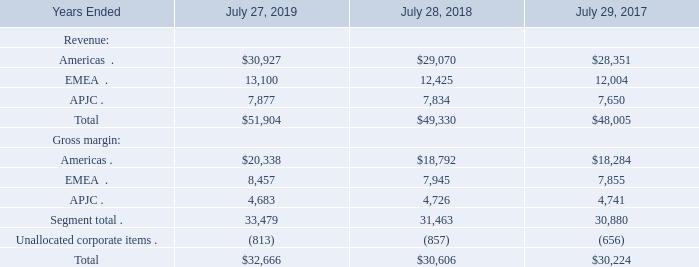(a) Revenue and Gross Margin by Segment
We conduct business globally and are managed on a geographic basis consisting of three segments: the Americas, EMEA, and APJC. Our management makes financial decisions and allocates resources based on the information it receives from our internal management system. Sales are attributed to a segment based on the ordering location of the customer. We do not allocate research and development, sales and marketing, or general and administrative expenses to our segments in this internal management system because management does not include the information in our measurement of the performance of the operating segments. In addition, we do not allocate amortization and impairment of acquisition-related intangible assets, sharebased compensation expense, significant litigation settlements and other contingencies, charges related to asset impairments and restructurings, and certain other charges to the gross margin for each segment because management does not include this information in our measurement of the performance of the operating segments.
Summarized financial information by segment for fiscal 2019, 2018, and 2017, based on our internal management system and as utilized by our Chief Operating Decision Maker (CODM), is as follows (in millions):
Amounts may not sum and percentages may not recalculate due to rounding.
Revenue in the United States was $27.4 billion, $25.5 billion, and $25.0 billion for fiscal 2019, 2018, and 2017, respectively.
What was the revenue in the United States for fiscal 2018? $25.5 billion. What are the regions that the company operates in? Americas, emea, apjc. What was the gross margin from Americas in 2019?
Answer scale should be: million. 20,338. What was the change in the gross margin from APJC between 2017 and 2018?
Answer scale should be: million. 4,726-4,741
Answer: -15. How many years did total revenue from all segments exceed $50,000 million? 2019
Answer: 1. What was the percentage change in the total gross margin from all segments between 2018 and 2019?
Answer scale should be: percent. (32,666-30,606)/30,606
Answer: 6.73. 